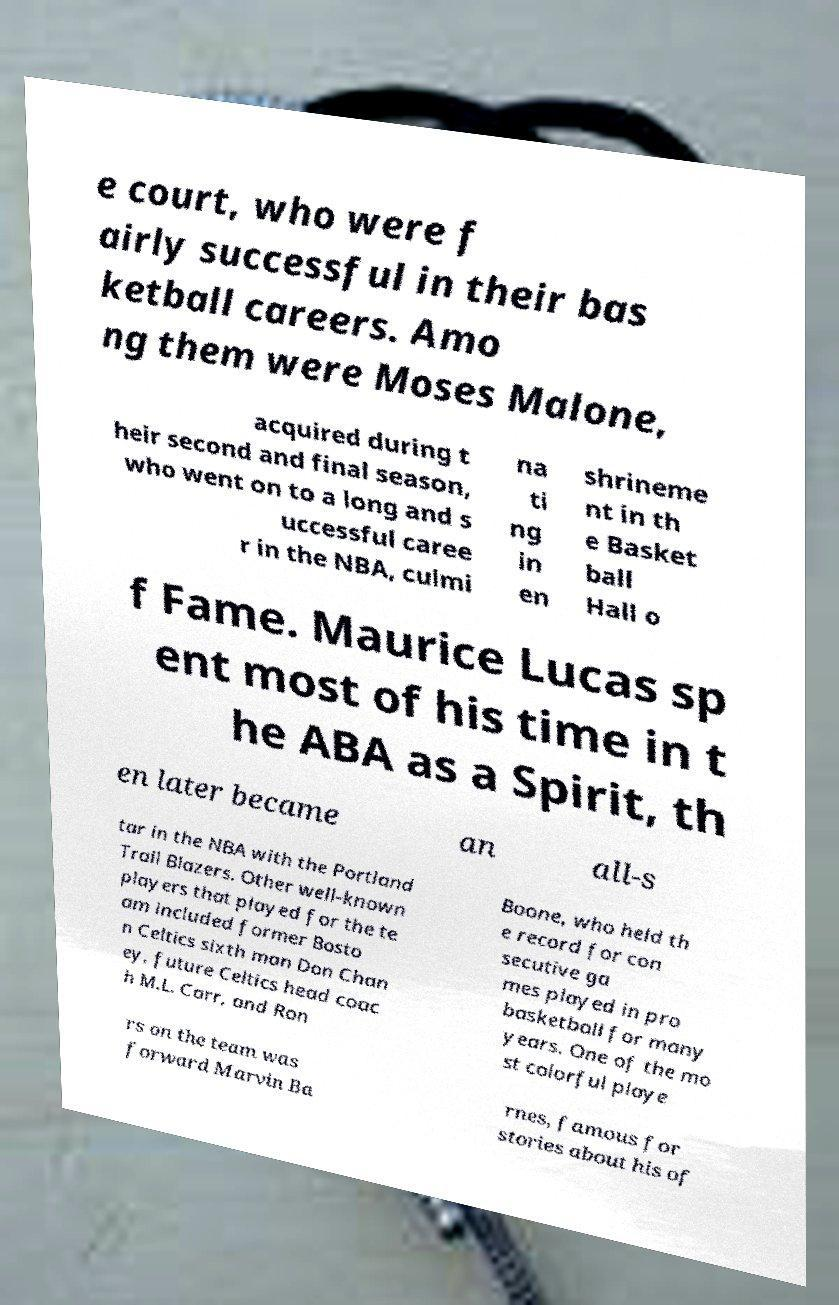What messages or text are displayed in this image? I need them in a readable, typed format. e court, who were f airly successful in their bas ketball careers. Amo ng them were Moses Malone, acquired during t heir second and final season, who went on to a long and s uccessful caree r in the NBA, culmi na ti ng in en shrineme nt in th e Basket ball Hall o f Fame. Maurice Lucas sp ent most of his time in t he ABA as a Spirit, th en later became an all-s tar in the NBA with the Portland Trail Blazers. Other well-known players that played for the te am included former Bosto n Celtics sixth man Don Chan ey, future Celtics head coac h M.L. Carr, and Ron Boone, who held th e record for con secutive ga mes played in pro basketball for many years. One of the mo st colorful playe rs on the team was forward Marvin Ba rnes, famous for stories about his of 